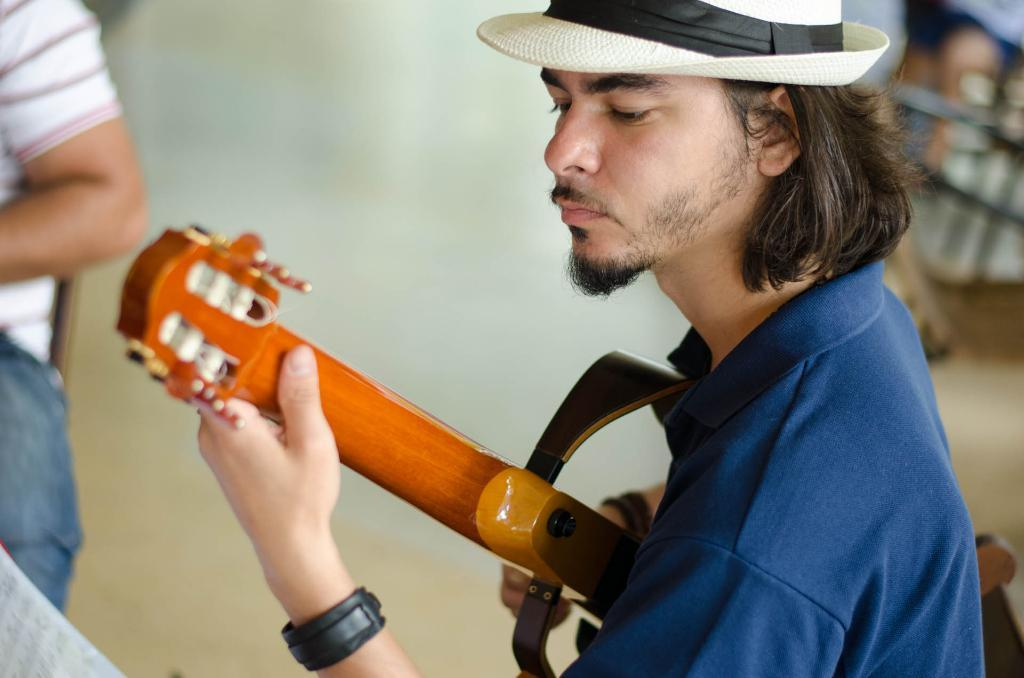What is the main subject of the image? There is a man in the image. What is the man holding in the image? The man is holding a guitar. What type of calculator can be seen on the man's shoulder in the image? There is no calculator present in the image, and the man's shoulder is not visible. 